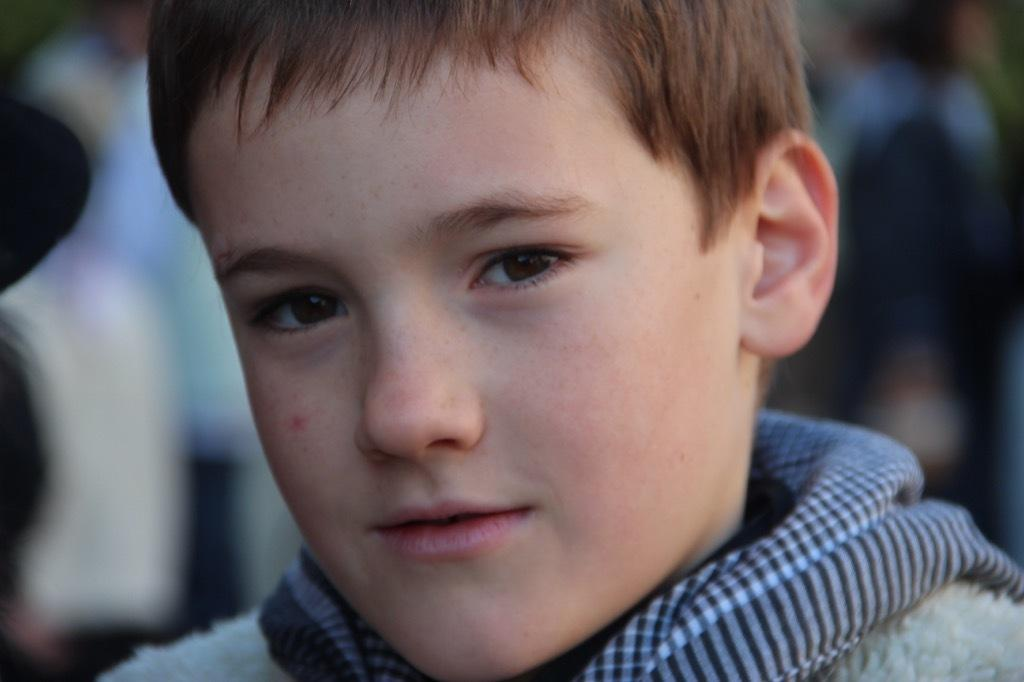Who is the main subject in the image? There is a boy in the image. What is the boy's expression in the image? The boy is smiling in the image. Can you describe the background of the image? The background of the image is blurred. How many stitches are visible on the boy's shirt in the image? There is no information about the boy's shirt or any stitches in the image. 